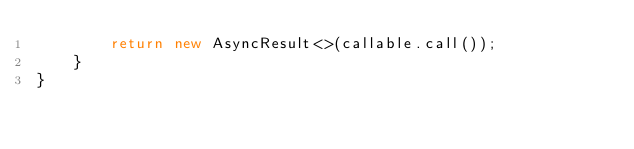Convert code to text. <code><loc_0><loc_0><loc_500><loc_500><_Java_>        return new AsyncResult<>(callable.call());
    }
}
</code> 